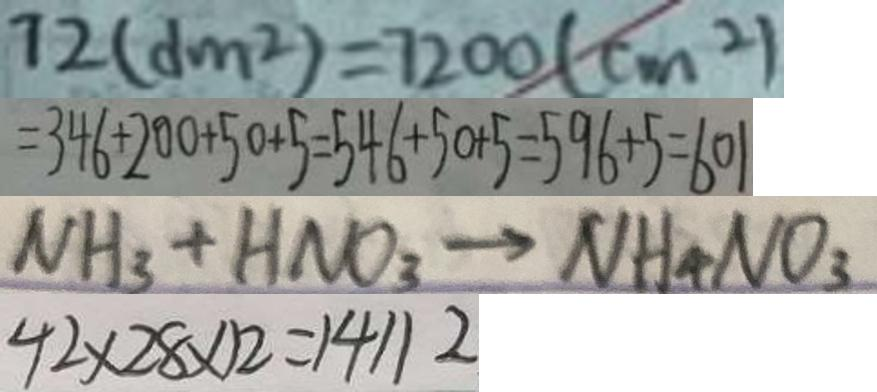<formula> <loc_0><loc_0><loc_500><loc_500>7 2 ( d m ^ { 2 } ) = 7 2 0 0 ( c m ^ { 2 } ) 
 = 3 4 6 + 2 0 0 + 5 0 + 5 = 5 4 6 + 5 0 + 5 = 5 9 6 + 5 = 6 0 1 
 N H _ { 3 } + H N O _ { 3 } \rightarrow N H _ { 4 } N O _ { 3 } 
 4 2 \times 2 8 \times 1 2 = 1 4 1 1 2</formula> 